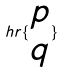Convert formula to latex. <formula><loc_0><loc_0><loc_500><loc_500>h r \{ \begin{matrix} p \\ q \end{matrix} \}</formula> 